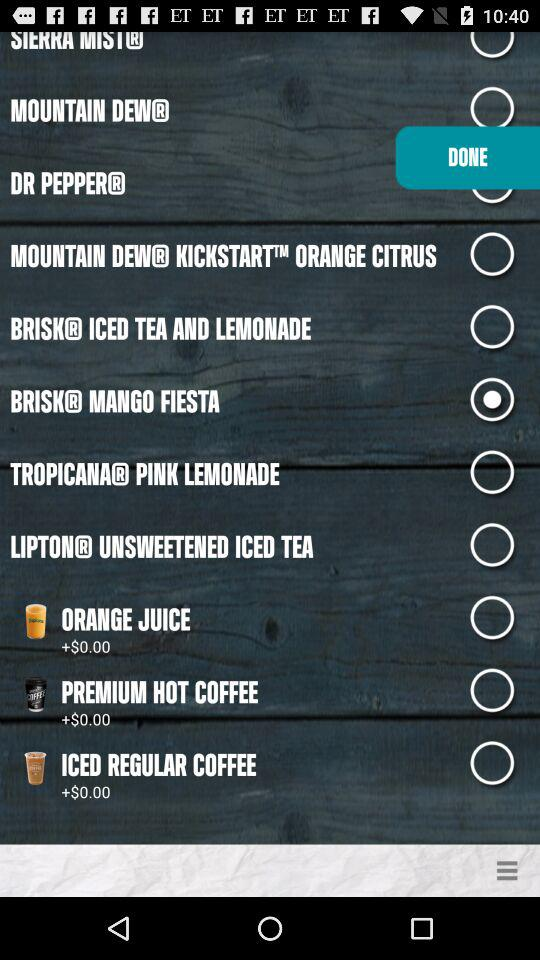What is the name of the application?
When the provided information is insufficient, respond with <no answer>. <no answer> 